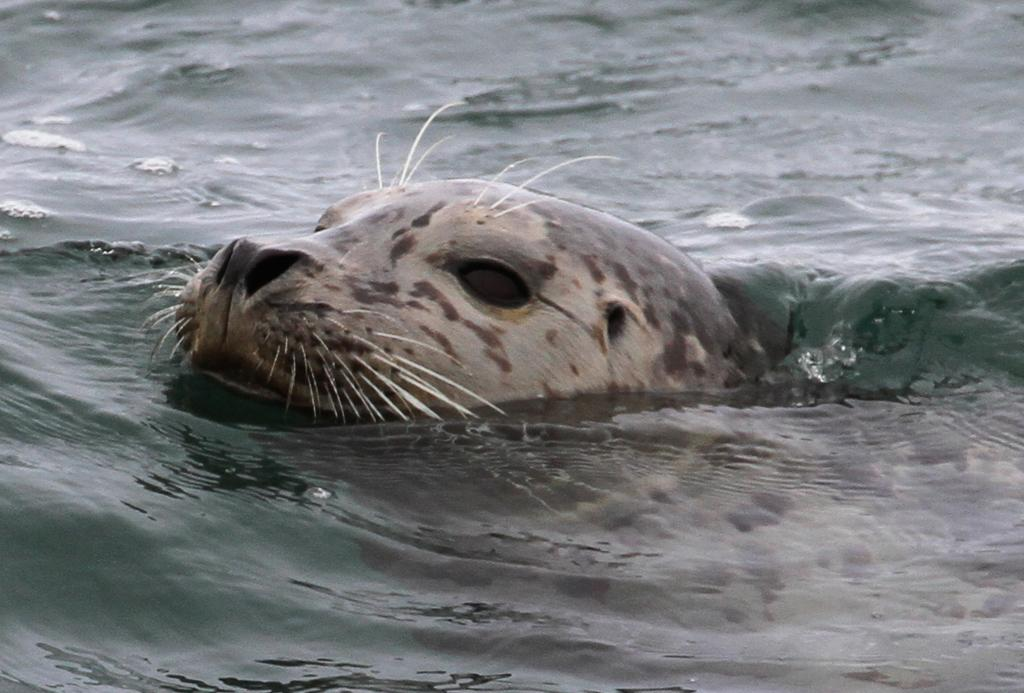Where was the image taken? The image is taken outdoors. What can be seen at the bottom of the image? There is a sea with water at the bottom of the image. What animal is present in the water in the middle of the image? There is a seal in the water in the middle of the image. Where is the cobweb located in the image? There is no cobweb present in the image. What type of action is the seal performing in the image? The image does not show the seal performing any specific action; it is simply swimming in the water. 